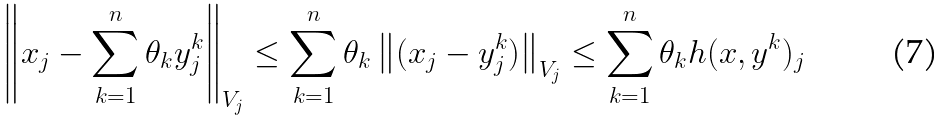<formula> <loc_0><loc_0><loc_500><loc_500>\left \| x _ { j } - \sum _ { k = 1 } ^ { n } \theta _ { k } y ^ { k } _ { j } \right \| _ { V _ { j } } \leq \sum _ { k = 1 } ^ { n } \theta _ { k } \left \| ( x _ { j } - y ^ { k } _ { j } ) \right \| _ { V _ { j } } \leq \sum _ { k = 1 } ^ { n } \theta _ { k } h ( x , y ^ { k } ) _ { j }</formula> 